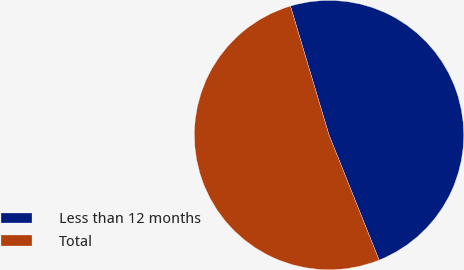Convert chart to OTSL. <chart><loc_0><loc_0><loc_500><loc_500><pie_chart><fcel>Less than 12 months<fcel>Total<nl><fcel>48.56%<fcel>51.44%<nl></chart> 